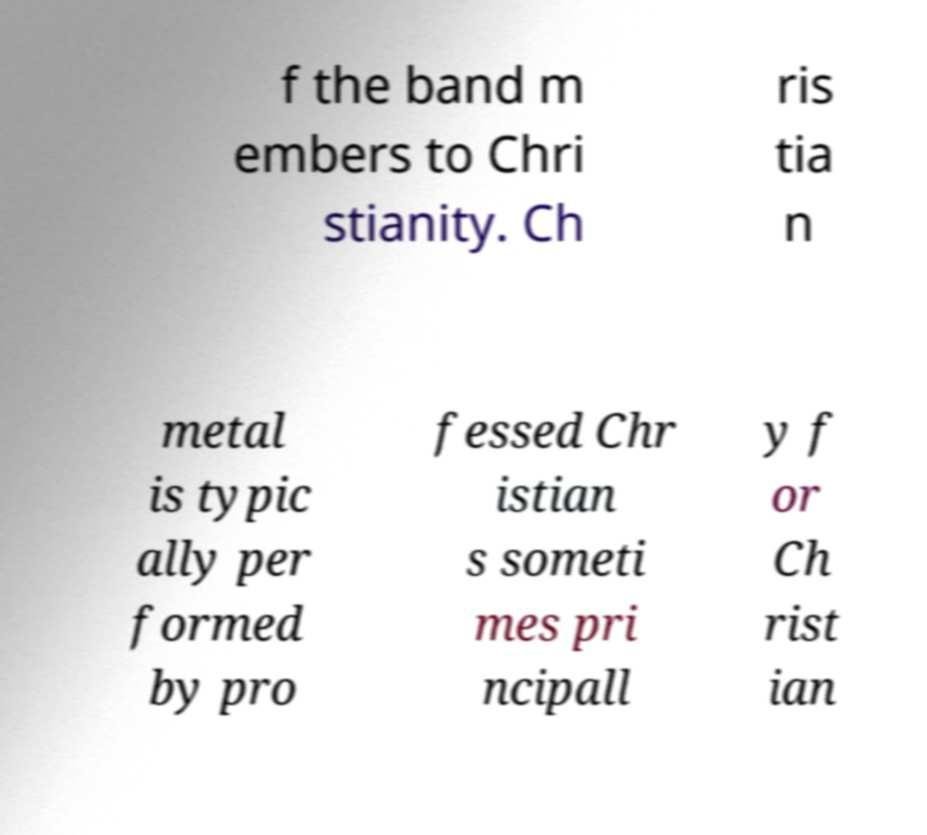Can you accurately transcribe the text from the provided image for me? f the band m embers to Chri stianity. Ch ris tia n metal is typic ally per formed by pro fessed Chr istian s someti mes pri ncipall y f or Ch rist ian 